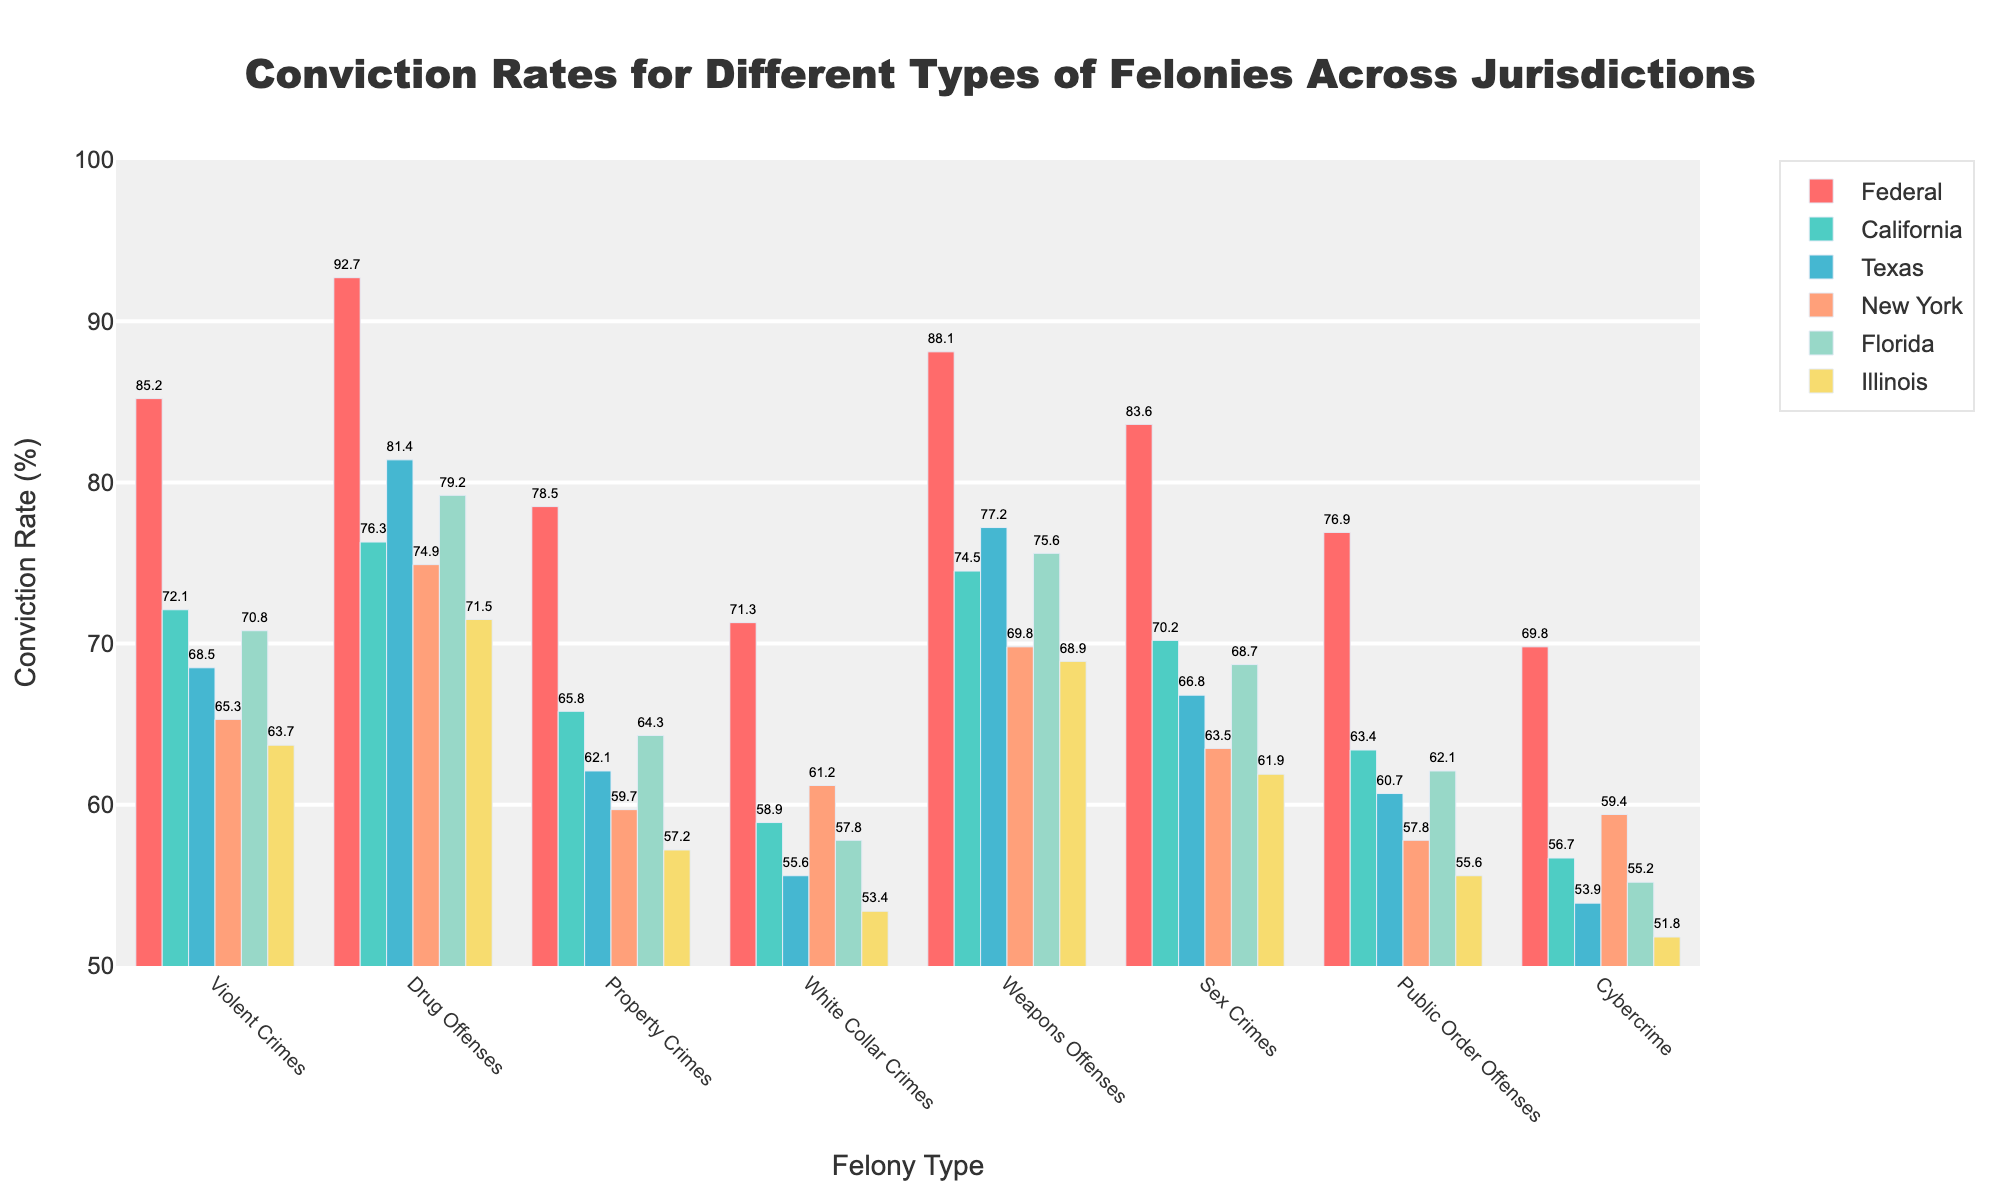Which jurisdiction has the highest conviction rate for drug offenses? We look for the highest bar in the "Drug Offenses" category. The highest bar color matches the Federal jurisdiction. The conviction rate is 92.7.
Answer: Federal For property crimes, how much higher is the conviction rate in California compared to Illinois? The conviction rate for property crimes in California is 65.8 while in Illinois it is 57.2. The difference is 65.8 - 57.2 = 8.6.
Answer: 8.6 Which felony type shows the smallest difference in conviction rates between Federal and Texas? We compare the differences for each felony type between Federal and Texas. The differences are calculated as follows: 
- Violent Crimes: 85.2 - 68.5 = 16.7
- Drug Offenses: 92.7 - 81.4 = 11.3
- Property Crimes: 78.5 - 62.1 = 16.4
- White Collar Crimes: 71.3 - 55.6 = 15.7
- Weapons Offenses: 88.1 - 77.2 = 10.9
- Sex Crimes: 83.6 - 66.8 = 16.8
- Public Order Offenses: 76.9 - 60.7 = 16.2
- Cybercrime: 69.8 - 53.9 = 15.9
The smallest difference is for Weapons Offenses, with 10.9.
Answer: Weapons Offenses What is the average conviction rate for sex crimes across all jurisdictions? To compute the average, sum the conviction rates for sex crimes across all jurisdictions and divide by the number of jurisdictions: (83.6 + 70.2 + 66.8 + 63.5 + 68.7 + 61.9)/6 = 69.783.
Answer: 69.8 In which felony type do the conviction rates span the largest range (difference between highest and lowest rates) across jurisdictions? Calculate the range (highest - lowest) for each felony type:
- Violent Crimes: 85.2 - 63.7 = 21.5
- Drug Offenses: 92.7 - 71.5 = 21.2
- Property Crimes: 78.5 - 57.2 = 21.3
- White Collar Crimes: 71.3 - 53.4 = 17.9
- Weapons Offenses: 88.1 - 68.9 = 19.2
- Sex Crimes: 83.6 - 61.9 = 21.7
- Public Order Offenses: 76.9 - 55.6 = 21.3
- Cybercrime: 69.8 - 51.8 = 18.0
The largest range is found in Sex Crimes, with a 21.7 point difference.
Answer: Sex Crimes Identify the jurisdiction with the lowest average conviction rate across all felony types. First, compute the average conviction rate for each jurisdiction:
- Federal: (85.2 + 92.7 + 78.5 + 71.3 + 88.1 + 83.6 + 76.9 + 69.8) / 8 = 80.775
- California: (72.1 + 76.3 + 65.8 + 58.9 + 74.5 + 70.2 + 63.4 + 56.7) / 8 = 67.36
- Texas: (68.5 + 81.4 + 62.1 + 55.6 + 77.2 + 66.8 + 60.7 + 53.9) / 8 = 65.775
- New York: (65.3 + 74.9 + 59.7 + 61.2 + 69.8 + 63.5 + 57.8 + 59.4) / 8 = 63.2
- Florida: (70.8 + 79.2 + 64.3 + 57.8 + 75.6 + 68.7 + 62.1 + 55.2) / 8 = 66.4625
- Illinois: (63.7 + 71.5 + 57.2 + 53.4 + 68.9 + 61.9 + 55.6 + 51.8) / 8 = 60.5
The lowest average conviction rate is in Illinois, with 60.5.
Answer: Illinois 